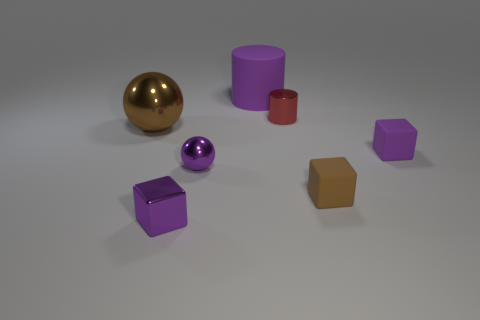What is the color of the matte thing that is right of the small brown thing? purple 